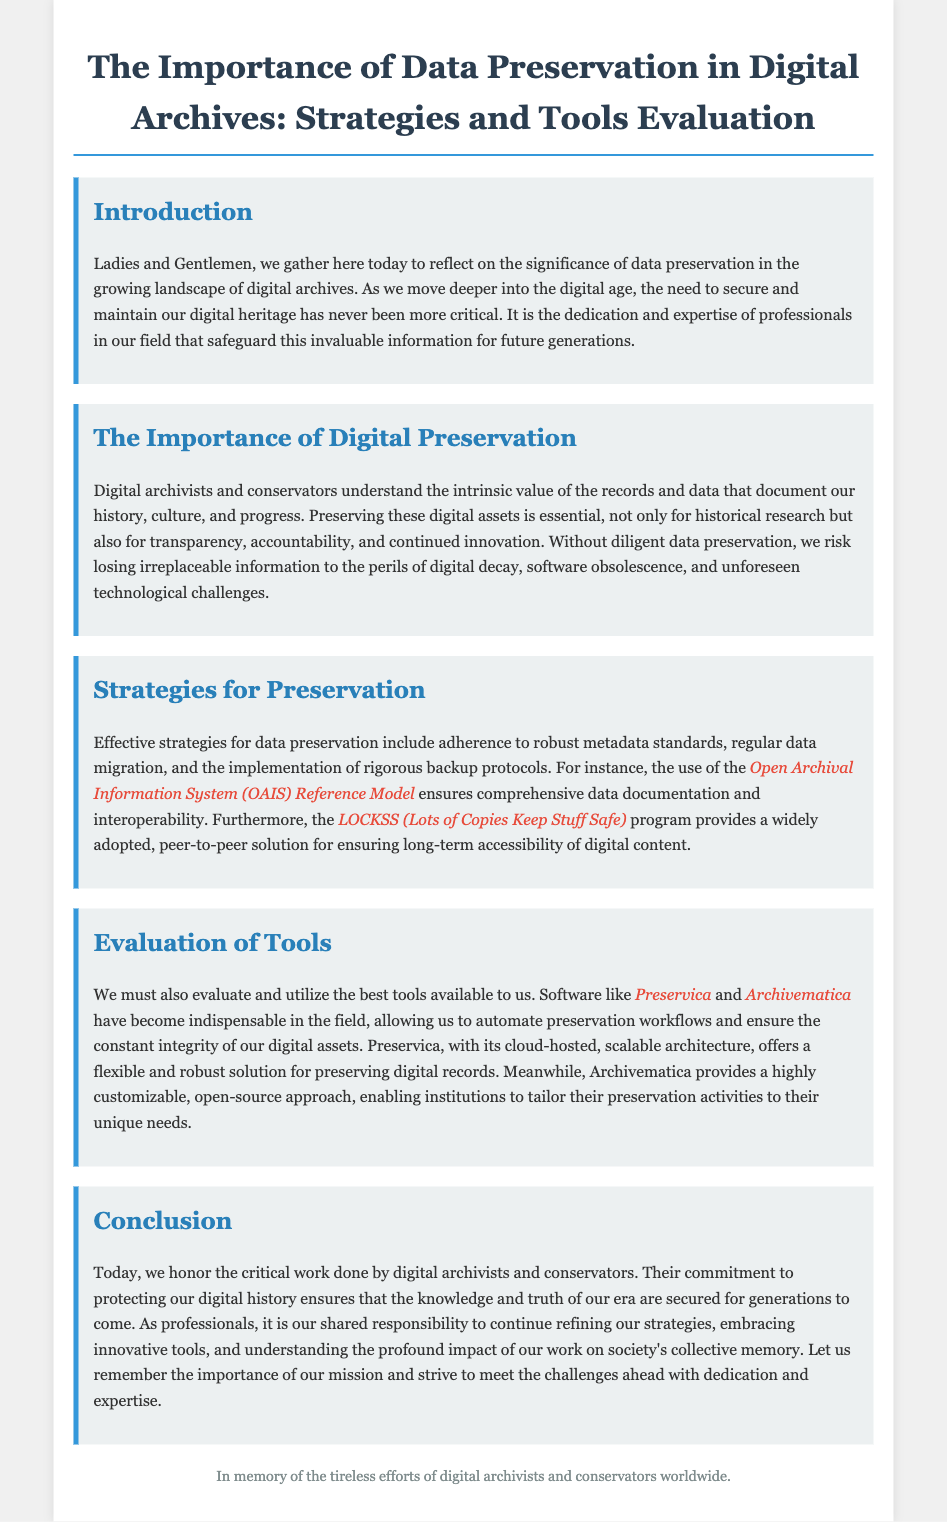What is the title of the document? The title is prominently displayed at the top of the document, which states the subject matter being addressed.
Answer: The Importance of Data Preservation in Digital Archives: Strategies and Tools Evaluation What does OAIS stand for? OAIS is mentioned as part of the preservation strategies outlined in the document, indicating its significance in the context of digital archiving.
Answer: Open Archival Information System What software is mentioned as indispensable for digital preservation? The document lists specific software tools that are essential in the field of digital archiving.
Answer: Preservica and Archivematica What is the main purpose of digital preservation according to the document? The text describes the significance of this practice for various aspects, including history and accountability.
Answer: To secure and maintain our digital heritage What program ensures long-term accessibility of digital content? The document references a specific program known for its focus on ensuring the accessibility of digital materials.
Answer: LOCKSS What is one strategy for data preservation mentioned? The document outlines various strategies that can be applied for effective data preservation in digital archives.
Answer: Regular data migration What type of approach does Archivematica provide? The document describes the nature of the software's approach in relation to customization for preservation activities.
Answer: Open-source approach Why is data preservation critical according to the document? The text emphasizes the risks associated with failing to preserve digital data, highlighting its importance.
Answer: To prevent losing irreplaceable information Who are honored in the conclusion of the document? The conclusion expresses gratitude towards a particular group responsible for maintaining digital records.
Answer: Digital archivists and conservators 